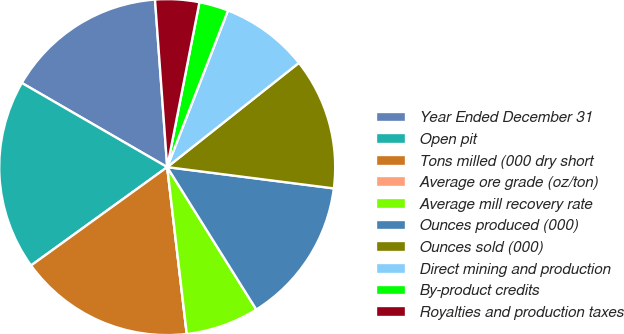<chart> <loc_0><loc_0><loc_500><loc_500><pie_chart><fcel>Year Ended December 31<fcel>Open pit<fcel>Tons milled (000 dry short<fcel>Average ore grade (oz/ton)<fcel>Average mill recovery rate<fcel>Ounces produced (000)<fcel>Ounces sold (000)<fcel>Direct mining and production<fcel>By-product credits<fcel>Royalties and production taxes<nl><fcel>15.49%<fcel>18.31%<fcel>16.9%<fcel>0.0%<fcel>7.04%<fcel>14.08%<fcel>12.68%<fcel>8.45%<fcel>2.82%<fcel>4.23%<nl></chart> 